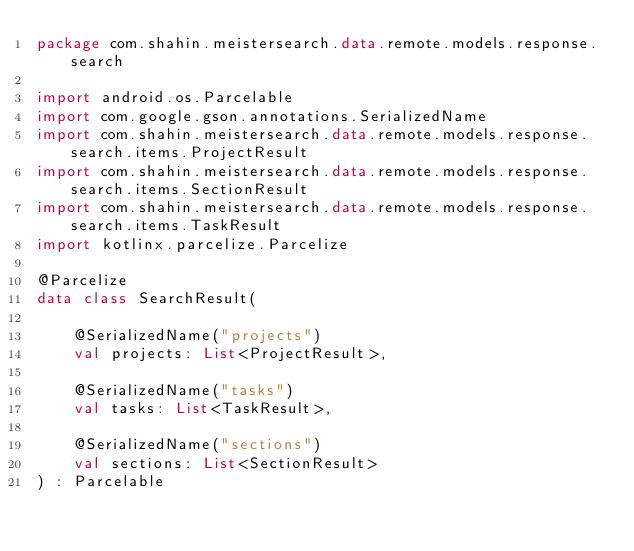<code> <loc_0><loc_0><loc_500><loc_500><_Kotlin_>package com.shahin.meistersearch.data.remote.models.response.search

import android.os.Parcelable
import com.google.gson.annotations.SerializedName
import com.shahin.meistersearch.data.remote.models.response.search.items.ProjectResult
import com.shahin.meistersearch.data.remote.models.response.search.items.SectionResult
import com.shahin.meistersearch.data.remote.models.response.search.items.TaskResult
import kotlinx.parcelize.Parcelize

@Parcelize
data class SearchResult(

    @SerializedName("projects")
    val projects: List<ProjectResult>,

    @SerializedName("tasks")
    val tasks: List<TaskResult>,

    @SerializedName("sections")
    val sections: List<SectionResult>
) : Parcelable</code> 